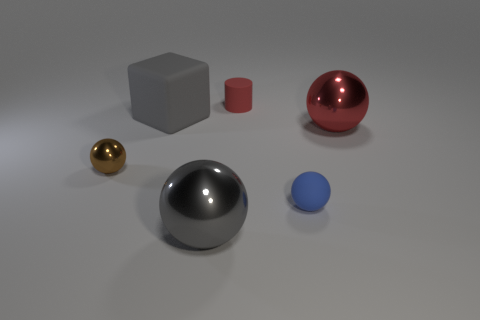What number of small balls are there?
Your response must be concise. 2. There is a small object that is in front of the red shiny object and to the left of the blue thing; what shape is it?
Your answer should be very brief. Sphere. There is a large object in front of the small brown metallic ball; is its color the same as the tiny rubber thing that is behind the big red ball?
Your response must be concise. No. What size is the thing that is the same color as the large rubber block?
Provide a short and direct response. Large. Is there a large red sphere made of the same material as the tiny cylinder?
Your answer should be compact. No. Is the number of red matte cylinders that are on the left side of the small metallic sphere the same as the number of brown metal objects behind the cylinder?
Your response must be concise. Yes. There is a sphere that is on the left side of the big gray shiny object; what is its size?
Your answer should be compact. Small. What material is the tiny sphere right of the large metallic thing that is in front of the brown shiny ball?
Keep it short and to the point. Rubber. How many red cylinders are left of the big object that is to the right of the rubber thing that is to the right of the red matte cylinder?
Offer a terse response. 1. Are the tiny sphere behind the tiny blue thing and the small object behind the large red metal thing made of the same material?
Provide a succinct answer. No. 